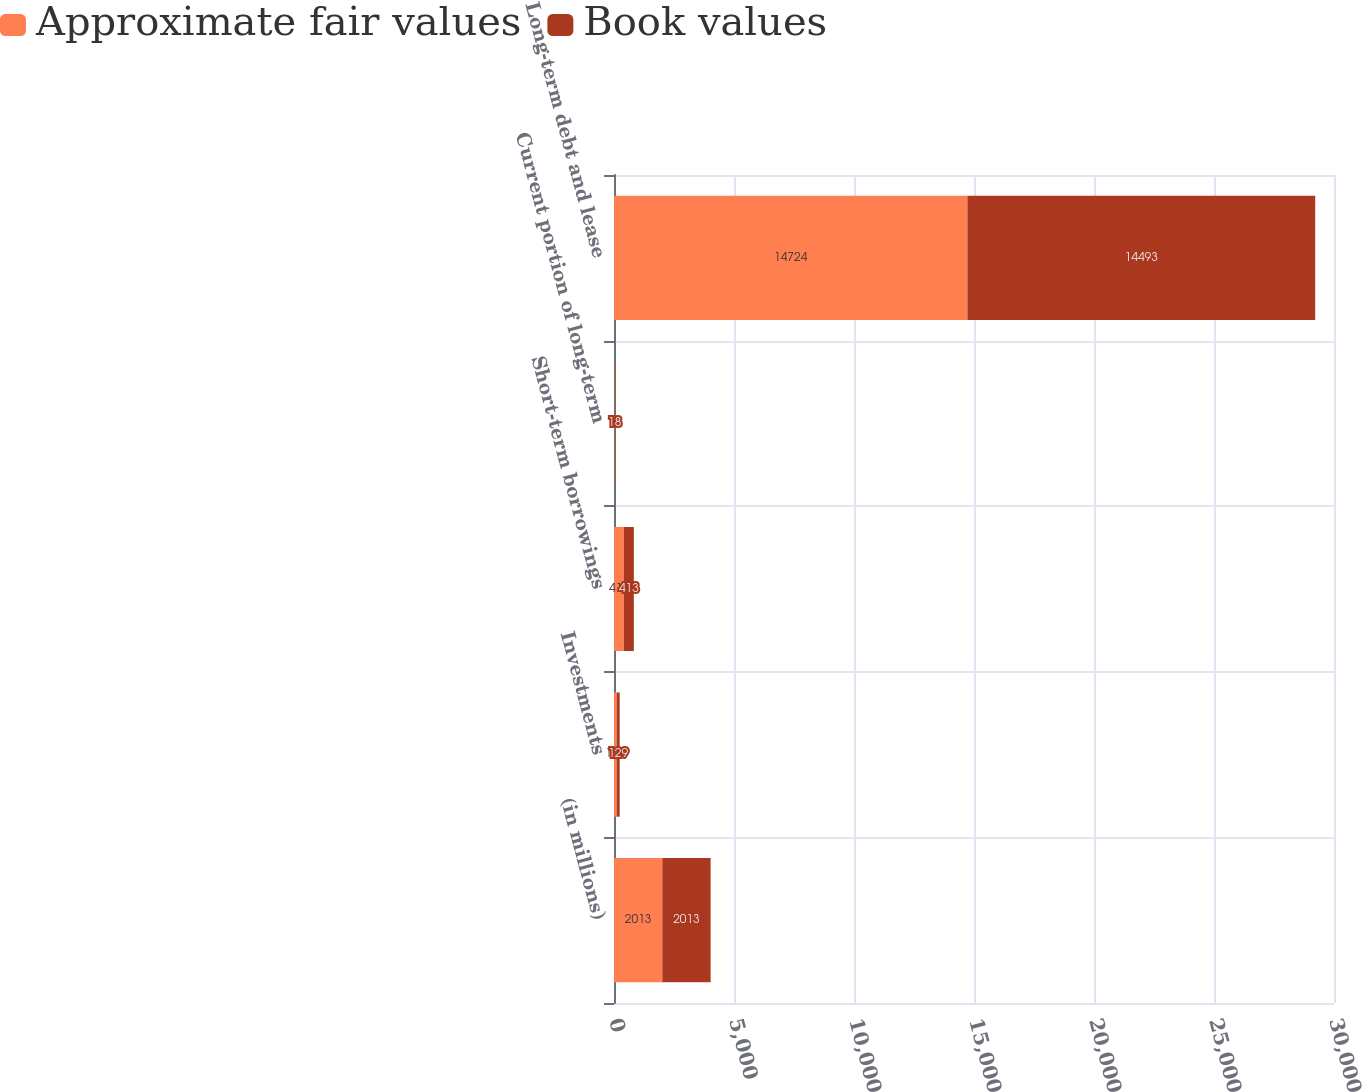Convert chart. <chart><loc_0><loc_0><loc_500><loc_500><stacked_bar_chart><ecel><fcel>(in millions)<fcel>Investments<fcel>Short-term borrowings<fcel>Current portion of long-term<fcel>Long-term debt and lease<nl><fcel>Approximate fair values<fcel>2013<fcel>108<fcel>413<fcel>18<fcel>14724<nl><fcel>Book values<fcel>2013<fcel>129<fcel>413<fcel>18<fcel>14493<nl></chart> 